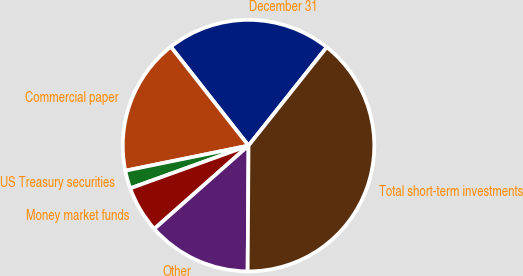Convert chart. <chart><loc_0><loc_0><loc_500><loc_500><pie_chart><fcel>December 31<fcel>Commercial paper<fcel>US Treasury securities<fcel>Money market funds<fcel>Other<fcel>Total short-term investments<nl><fcel>21.29%<fcel>17.6%<fcel>2.32%<fcel>6.0%<fcel>13.37%<fcel>39.43%<nl></chart> 